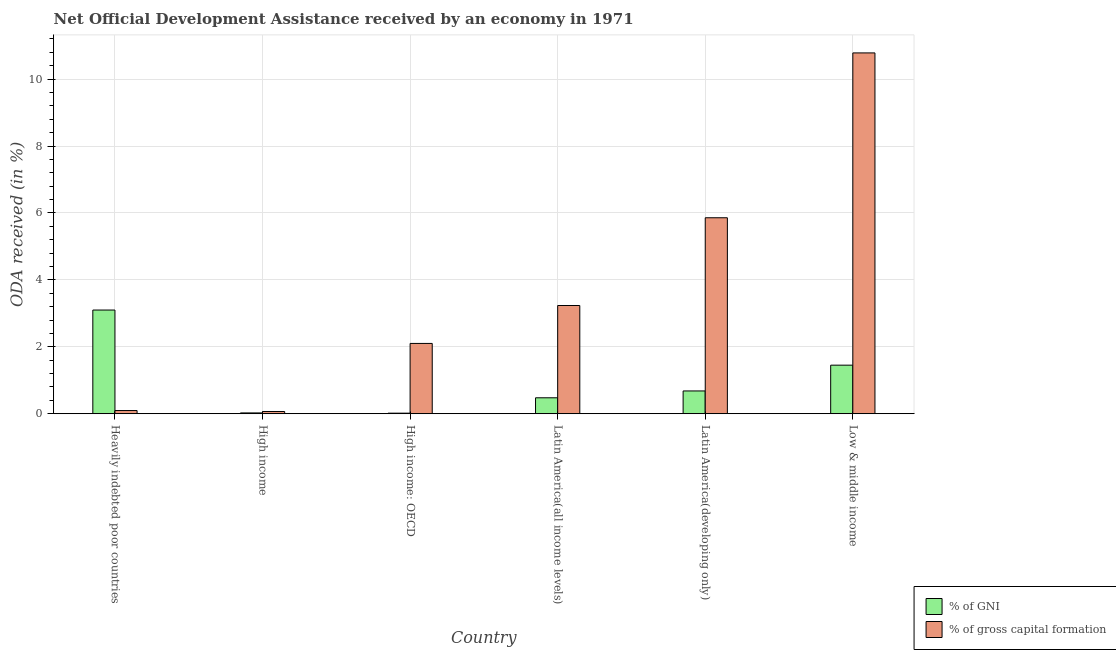How many different coloured bars are there?
Make the answer very short. 2. Are the number of bars on each tick of the X-axis equal?
Provide a succinct answer. Yes. How many bars are there on the 1st tick from the left?
Provide a short and direct response. 2. How many bars are there on the 3rd tick from the right?
Provide a succinct answer. 2. What is the label of the 3rd group of bars from the left?
Give a very brief answer. High income: OECD. What is the oda received as percentage of gross capital formation in High income: OECD?
Your answer should be compact. 2.1. Across all countries, what is the maximum oda received as percentage of gross capital formation?
Provide a short and direct response. 10.78. Across all countries, what is the minimum oda received as percentage of gni?
Offer a very short reply. 0.02. In which country was the oda received as percentage of gni maximum?
Your response must be concise. Heavily indebted poor countries. In which country was the oda received as percentage of gni minimum?
Your answer should be compact. High income: OECD. What is the total oda received as percentage of gross capital formation in the graph?
Offer a terse response. 22.14. What is the difference between the oda received as percentage of gross capital formation in High income: OECD and that in Low & middle income?
Give a very brief answer. -8.68. What is the difference between the oda received as percentage of gni in Heavily indebted poor countries and the oda received as percentage of gross capital formation in Low & middle income?
Make the answer very short. -7.68. What is the average oda received as percentage of gni per country?
Provide a short and direct response. 0.96. What is the difference between the oda received as percentage of gni and oda received as percentage of gross capital formation in High income?
Your response must be concise. -0.04. In how many countries, is the oda received as percentage of gni greater than 2.8 %?
Provide a short and direct response. 1. What is the ratio of the oda received as percentage of gni in Latin America(all income levels) to that in Latin America(developing only)?
Keep it short and to the point. 0.7. Is the oda received as percentage of gni in Latin America(all income levels) less than that in Low & middle income?
Provide a short and direct response. Yes. What is the difference between the highest and the second highest oda received as percentage of gni?
Offer a terse response. 1.65. What is the difference between the highest and the lowest oda received as percentage of gni?
Make the answer very short. 3.08. What does the 2nd bar from the left in High income: OECD represents?
Provide a short and direct response. % of gross capital formation. What does the 2nd bar from the right in Latin America(developing only) represents?
Ensure brevity in your answer.  % of GNI. How many bars are there?
Keep it short and to the point. 12. Are all the bars in the graph horizontal?
Give a very brief answer. No. What is the difference between two consecutive major ticks on the Y-axis?
Make the answer very short. 2. Where does the legend appear in the graph?
Offer a very short reply. Bottom right. How are the legend labels stacked?
Make the answer very short. Vertical. What is the title of the graph?
Make the answer very short. Net Official Development Assistance received by an economy in 1971. Does "Foreign Liabilities" appear as one of the legend labels in the graph?
Offer a very short reply. No. What is the label or title of the Y-axis?
Provide a succinct answer. ODA received (in %). What is the ODA received (in %) in % of GNI in Heavily indebted poor countries?
Make the answer very short. 3.1. What is the ODA received (in %) in % of gross capital formation in Heavily indebted poor countries?
Provide a succinct answer. 0.1. What is the ODA received (in %) of % of GNI in High income?
Your response must be concise. 0.02. What is the ODA received (in %) of % of gross capital formation in High income?
Ensure brevity in your answer.  0.07. What is the ODA received (in %) in % of GNI in High income: OECD?
Offer a very short reply. 0.02. What is the ODA received (in %) in % of gross capital formation in High income: OECD?
Ensure brevity in your answer.  2.1. What is the ODA received (in %) of % of GNI in Latin America(all income levels)?
Your answer should be very brief. 0.48. What is the ODA received (in %) of % of gross capital formation in Latin America(all income levels)?
Offer a terse response. 3.23. What is the ODA received (in %) of % of GNI in Latin America(developing only)?
Ensure brevity in your answer.  0.68. What is the ODA received (in %) in % of gross capital formation in Latin America(developing only)?
Keep it short and to the point. 5.86. What is the ODA received (in %) of % of GNI in Low & middle income?
Your answer should be very brief. 1.45. What is the ODA received (in %) of % of gross capital formation in Low & middle income?
Your answer should be compact. 10.78. Across all countries, what is the maximum ODA received (in %) in % of GNI?
Your answer should be compact. 3.1. Across all countries, what is the maximum ODA received (in %) of % of gross capital formation?
Provide a short and direct response. 10.78. Across all countries, what is the minimum ODA received (in %) in % of GNI?
Keep it short and to the point. 0.02. Across all countries, what is the minimum ODA received (in %) in % of gross capital formation?
Provide a succinct answer. 0.07. What is the total ODA received (in %) in % of GNI in the graph?
Provide a short and direct response. 5.75. What is the total ODA received (in %) of % of gross capital formation in the graph?
Your response must be concise. 22.14. What is the difference between the ODA received (in %) of % of GNI in Heavily indebted poor countries and that in High income?
Offer a terse response. 3.07. What is the difference between the ODA received (in %) in % of gross capital formation in Heavily indebted poor countries and that in High income?
Provide a short and direct response. 0.03. What is the difference between the ODA received (in %) of % of GNI in Heavily indebted poor countries and that in High income: OECD?
Give a very brief answer. 3.08. What is the difference between the ODA received (in %) of % of gross capital formation in Heavily indebted poor countries and that in High income: OECD?
Give a very brief answer. -2.01. What is the difference between the ODA received (in %) of % of GNI in Heavily indebted poor countries and that in Latin America(all income levels)?
Your response must be concise. 2.62. What is the difference between the ODA received (in %) of % of gross capital formation in Heavily indebted poor countries and that in Latin America(all income levels)?
Keep it short and to the point. -3.14. What is the difference between the ODA received (in %) in % of GNI in Heavily indebted poor countries and that in Latin America(developing only)?
Your answer should be compact. 2.42. What is the difference between the ODA received (in %) of % of gross capital formation in Heavily indebted poor countries and that in Latin America(developing only)?
Your response must be concise. -5.76. What is the difference between the ODA received (in %) in % of GNI in Heavily indebted poor countries and that in Low & middle income?
Ensure brevity in your answer.  1.65. What is the difference between the ODA received (in %) of % of gross capital formation in Heavily indebted poor countries and that in Low & middle income?
Make the answer very short. -10.69. What is the difference between the ODA received (in %) in % of GNI in High income and that in High income: OECD?
Offer a terse response. 0.01. What is the difference between the ODA received (in %) of % of gross capital formation in High income and that in High income: OECD?
Ensure brevity in your answer.  -2.03. What is the difference between the ODA received (in %) of % of GNI in High income and that in Latin America(all income levels)?
Your answer should be compact. -0.45. What is the difference between the ODA received (in %) in % of gross capital formation in High income and that in Latin America(all income levels)?
Make the answer very short. -3.17. What is the difference between the ODA received (in %) of % of GNI in High income and that in Latin America(developing only)?
Make the answer very short. -0.66. What is the difference between the ODA received (in %) in % of gross capital formation in High income and that in Latin America(developing only)?
Give a very brief answer. -5.79. What is the difference between the ODA received (in %) of % of GNI in High income and that in Low & middle income?
Offer a very short reply. -1.43. What is the difference between the ODA received (in %) of % of gross capital formation in High income and that in Low & middle income?
Ensure brevity in your answer.  -10.72. What is the difference between the ODA received (in %) in % of GNI in High income: OECD and that in Latin America(all income levels)?
Offer a terse response. -0.46. What is the difference between the ODA received (in %) of % of gross capital formation in High income: OECD and that in Latin America(all income levels)?
Ensure brevity in your answer.  -1.13. What is the difference between the ODA received (in %) in % of GNI in High income: OECD and that in Latin America(developing only)?
Ensure brevity in your answer.  -0.66. What is the difference between the ODA received (in %) in % of gross capital formation in High income: OECD and that in Latin America(developing only)?
Provide a short and direct response. -3.76. What is the difference between the ODA received (in %) of % of GNI in High income: OECD and that in Low & middle income?
Ensure brevity in your answer.  -1.43. What is the difference between the ODA received (in %) in % of gross capital formation in High income: OECD and that in Low & middle income?
Give a very brief answer. -8.68. What is the difference between the ODA received (in %) of % of GNI in Latin America(all income levels) and that in Latin America(developing only)?
Offer a very short reply. -0.2. What is the difference between the ODA received (in %) in % of gross capital formation in Latin America(all income levels) and that in Latin America(developing only)?
Make the answer very short. -2.62. What is the difference between the ODA received (in %) in % of GNI in Latin America(all income levels) and that in Low & middle income?
Offer a very short reply. -0.97. What is the difference between the ODA received (in %) of % of gross capital formation in Latin America(all income levels) and that in Low & middle income?
Your response must be concise. -7.55. What is the difference between the ODA received (in %) of % of GNI in Latin America(developing only) and that in Low & middle income?
Provide a short and direct response. -0.77. What is the difference between the ODA received (in %) in % of gross capital formation in Latin America(developing only) and that in Low & middle income?
Your answer should be compact. -4.93. What is the difference between the ODA received (in %) in % of GNI in Heavily indebted poor countries and the ODA received (in %) in % of gross capital formation in High income?
Provide a succinct answer. 3.03. What is the difference between the ODA received (in %) in % of GNI in Heavily indebted poor countries and the ODA received (in %) in % of gross capital formation in High income: OECD?
Give a very brief answer. 1. What is the difference between the ODA received (in %) of % of GNI in Heavily indebted poor countries and the ODA received (in %) of % of gross capital formation in Latin America(all income levels)?
Offer a very short reply. -0.14. What is the difference between the ODA received (in %) in % of GNI in Heavily indebted poor countries and the ODA received (in %) in % of gross capital formation in Latin America(developing only)?
Ensure brevity in your answer.  -2.76. What is the difference between the ODA received (in %) of % of GNI in Heavily indebted poor countries and the ODA received (in %) of % of gross capital formation in Low & middle income?
Your answer should be very brief. -7.68. What is the difference between the ODA received (in %) of % of GNI in High income and the ODA received (in %) of % of gross capital formation in High income: OECD?
Offer a very short reply. -2.08. What is the difference between the ODA received (in %) of % of GNI in High income and the ODA received (in %) of % of gross capital formation in Latin America(all income levels)?
Provide a succinct answer. -3.21. What is the difference between the ODA received (in %) in % of GNI in High income and the ODA received (in %) in % of gross capital formation in Latin America(developing only)?
Offer a very short reply. -5.83. What is the difference between the ODA received (in %) in % of GNI in High income and the ODA received (in %) in % of gross capital formation in Low & middle income?
Offer a very short reply. -10.76. What is the difference between the ODA received (in %) of % of GNI in High income: OECD and the ODA received (in %) of % of gross capital formation in Latin America(all income levels)?
Your answer should be very brief. -3.22. What is the difference between the ODA received (in %) in % of GNI in High income: OECD and the ODA received (in %) in % of gross capital formation in Latin America(developing only)?
Make the answer very short. -5.84. What is the difference between the ODA received (in %) in % of GNI in High income: OECD and the ODA received (in %) in % of gross capital formation in Low & middle income?
Provide a succinct answer. -10.77. What is the difference between the ODA received (in %) of % of GNI in Latin America(all income levels) and the ODA received (in %) of % of gross capital formation in Latin America(developing only)?
Provide a short and direct response. -5.38. What is the difference between the ODA received (in %) in % of GNI in Latin America(all income levels) and the ODA received (in %) in % of gross capital formation in Low & middle income?
Keep it short and to the point. -10.31. What is the difference between the ODA received (in %) in % of GNI in Latin America(developing only) and the ODA received (in %) in % of gross capital formation in Low & middle income?
Make the answer very short. -10.1. What is the average ODA received (in %) of % of GNI per country?
Give a very brief answer. 0.96. What is the average ODA received (in %) in % of gross capital formation per country?
Provide a succinct answer. 3.69. What is the difference between the ODA received (in %) in % of GNI and ODA received (in %) in % of gross capital formation in Heavily indebted poor countries?
Keep it short and to the point. 3. What is the difference between the ODA received (in %) in % of GNI and ODA received (in %) in % of gross capital formation in High income?
Offer a very short reply. -0.04. What is the difference between the ODA received (in %) of % of GNI and ODA received (in %) of % of gross capital formation in High income: OECD?
Ensure brevity in your answer.  -2.08. What is the difference between the ODA received (in %) in % of GNI and ODA received (in %) in % of gross capital formation in Latin America(all income levels)?
Make the answer very short. -2.76. What is the difference between the ODA received (in %) in % of GNI and ODA received (in %) in % of gross capital formation in Latin America(developing only)?
Your answer should be very brief. -5.18. What is the difference between the ODA received (in %) of % of GNI and ODA received (in %) of % of gross capital formation in Low & middle income?
Ensure brevity in your answer.  -9.33. What is the ratio of the ODA received (in %) in % of GNI in Heavily indebted poor countries to that in High income?
Offer a terse response. 125.64. What is the ratio of the ODA received (in %) of % of gross capital formation in Heavily indebted poor countries to that in High income?
Keep it short and to the point. 1.43. What is the ratio of the ODA received (in %) of % of GNI in Heavily indebted poor countries to that in High income: OECD?
Provide a succinct answer. 180.08. What is the ratio of the ODA received (in %) of % of gross capital formation in Heavily indebted poor countries to that in High income: OECD?
Give a very brief answer. 0.05. What is the ratio of the ODA received (in %) in % of GNI in Heavily indebted poor countries to that in Latin America(all income levels)?
Your response must be concise. 6.5. What is the ratio of the ODA received (in %) in % of gross capital formation in Heavily indebted poor countries to that in Latin America(all income levels)?
Your answer should be very brief. 0.03. What is the ratio of the ODA received (in %) of % of GNI in Heavily indebted poor countries to that in Latin America(developing only)?
Ensure brevity in your answer.  4.55. What is the ratio of the ODA received (in %) of % of gross capital formation in Heavily indebted poor countries to that in Latin America(developing only)?
Offer a very short reply. 0.02. What is the ratio of the ODA received (in %) in % of GNI in Heavily indebted poor countries to that in Low & middle income?
Ensure brevity in your answer.  2.14. What is the ratio of the ODA received (in %) of % of gross capital formation in Heavily indebted poor countries to that in Low & middle income?
Your response must be concise. 0.01. What is the ratio of the ODA received (in %) in % of GNI in High income to that in High income: OECD?
Your answer should be very brief. 1.43. What is the ratio of the ODA received (in %) in % of gross capital formation in High income to that in High income: OECD?
Provide a succinct answer. 0.03. What is the ratio of the ODA received (in %) in % of GNI in High income to that in Latin America(all income levels)?
Offer a very short reply. 0.05. What is the ratio of the ODA received (in %) of % of gross capital formation in High income to that in Latin America(all income levels)?
Provide a short and direct response. 0.02. What is the ratio of the ODA received (in %) of % of GNI in High income to that in Latin America(developing only)?
Offer a very short reply. 0.04. What is the ratio of the ODA received (in %) in % of gross capital formation in High income to that in Latin America(developing only)?
Provide a succinct answer. 0.01. What is the ratio of the ODA received (in %) in % of GNI in High income to that in Low & middle income?
Your answer should be compact. 0.02. What is the ratio of the ODA received (in %) of % of gross capital formation in High income to that in Low & middle income?
Keep it short and to the point. 0.01. What is the ratio of the ODA received (in %) of % of GNI in High income: OECD to that in Latin America(all income levels)?
Your response must be concise. 0.04. What is the ratio of the ODA received (in %) in % of gross capital formation in High income: OECD to that in Latin America(all income levels)?
Provide a short and direct response. 0.65. What is the ratio of the ODA received (in %) of % of GNI in High income: OECD to that in Latin America(developing only)?
Your answer should be compact. 0.03. What is the ratio of the ODA received (in %) in % of gross capital formation in High income: OECD to that in Latin America(developing only)?
Ensure brevity in your answer.  0.36. What is the ratio of the ODA received (in %) of % of GNI in High income: OECD to that in Low & middle income?
Offer a terse response. 0.01. What is the ratio of the ODA received (in %) in % of gross capital formation in High income: OECD to that in Low & middle income?
Offer a terse response. 0.19. What is the ratio of the ODA received (in %) of % of GNI in Latin America(all income levels) to that in Latin America(developing only)?
Ensure brevity in your answer.  0.7. What is the ratio of the ODA received (in %) of % of gross capital formation in Latin America(all income levels) to that in Latin America(developing only)?
Make the answer very short. 0.55. What is the ratio of the ODA received (in %) of % of GNI in Latin America(all income levels) to that in Low & middle income?
Your response must be concise. 0.33. What is the ratio of the ODA received (in %) of % of gross capital formation in Latin America(all income levels) to that in Low & middle income?
Your answer should be very brief. 0.3. What is the ratio of the ODA received (in %) in % of GNI in Latin America(developing only) to that in Low & middle income?
Offer a terse response. 0.47. What is the ratio of the ODA received (in %) of % of gross capital formation in Latin America(developing only) to that in Low & middle income?
Offer a very short reply. 0.54. What is the difference between the highest and the second highest ODA received (in %) in % of GNI?
Make the answer very short. 1.65. What is the difference between the highest and the second highest ODA received (in %) in % of gross capital formation?
Make the answer very short. 4.93. What is the difference between the highest and the lowest ODA received (in %) of % of GNI?
Ensure brevity in your answer.  3.08. What is the difference between the highest and the lowest ODA received (in %) in % of gross capital formation?
Your answer should be compact. 10.72. 